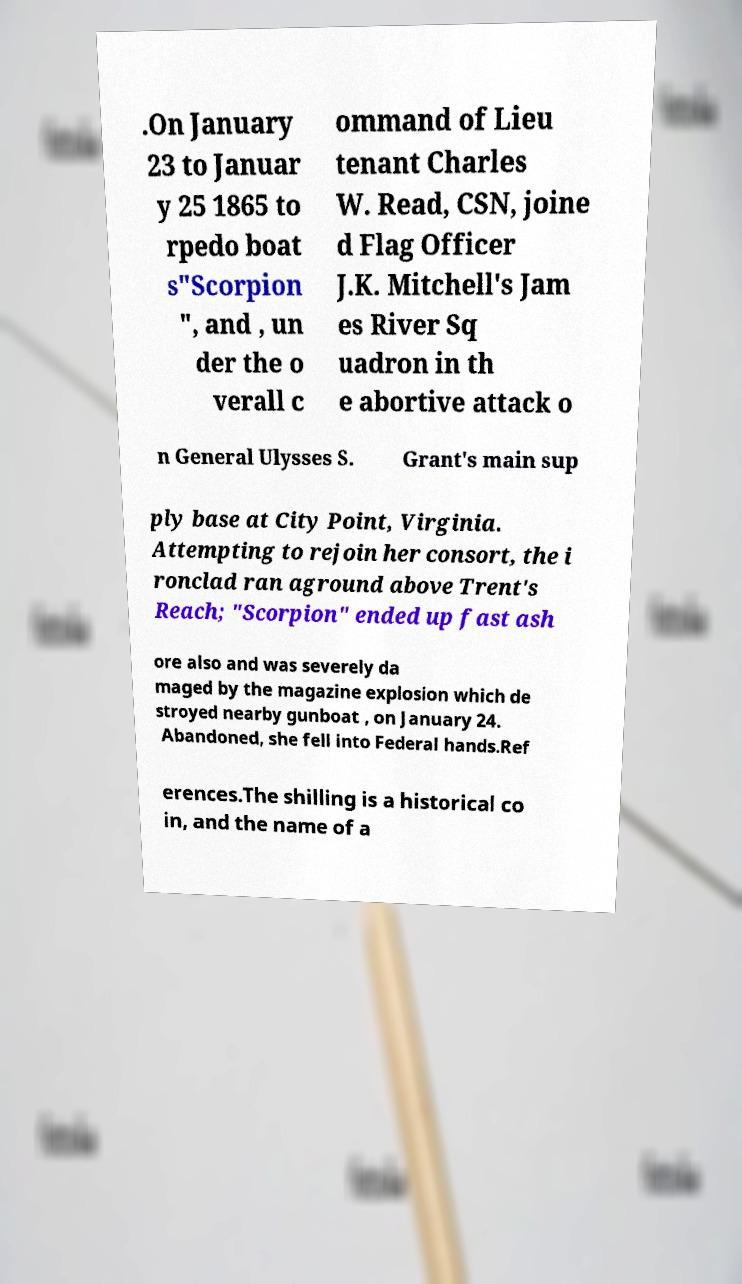Please read and relay the text visible in this image. What does it say? .On January 23 to Januar y 25 1865 to rpedo boat s"Scorpion ", and , un der the o verall c ommand of Lieu tenant Charles W. Read, CSN, joine d Flag Officer J.K. Mitchell's Jam es River Sq uadron in th e abortive attack o n General Ulysses S. Grant's main sup ply base at City Point, Virginia. Attempting to rejoin her consort, the i ronclad ran aground above Trent's Reach; "Scorpion" ended up fast ash ore also and was severely da maged by the magazine explosion which de stroyed nearby gunboat , on January 24. Abandoned, she fell into Federal hands.Ref erences.The shilling is a historical co in, and the name of a 